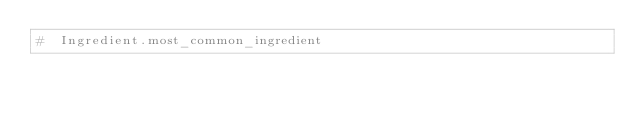<code> <loc_0><loc_0><loc_500><loc_500><_Ruby_>#  Ingredient.most_common_ingredient
</code> 